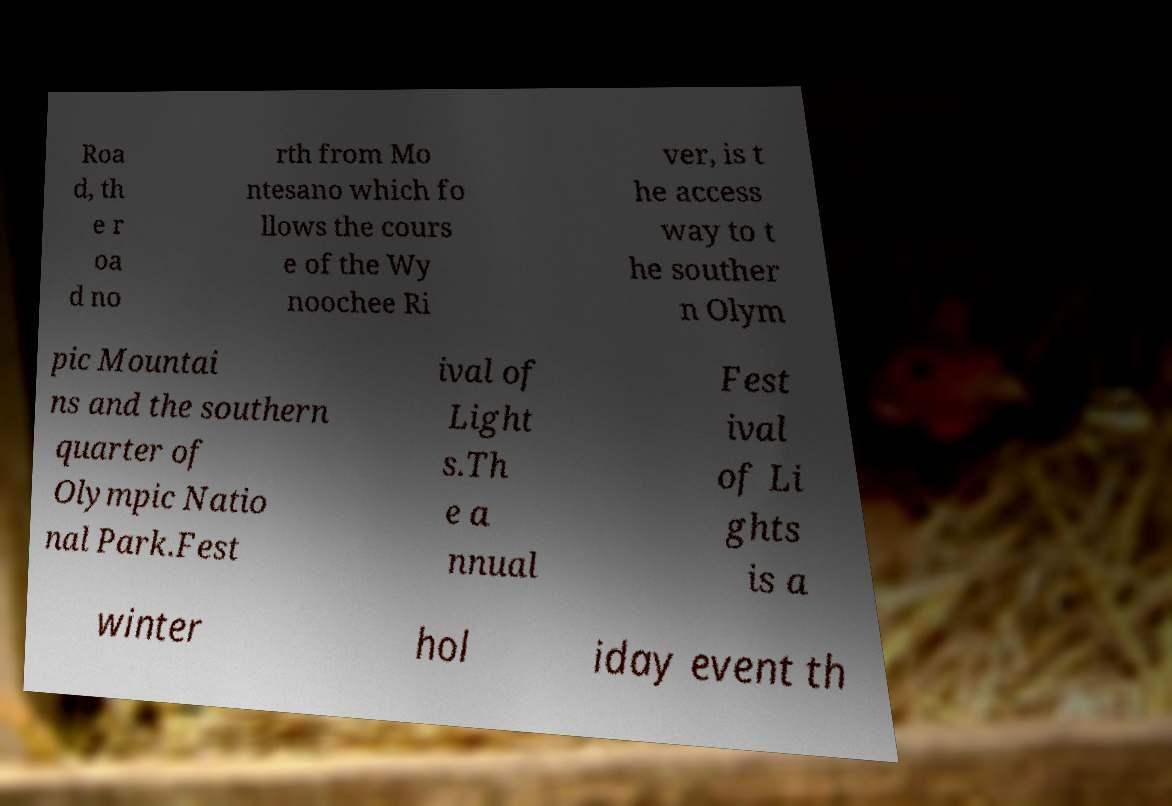Can you read and provide the text displayed in the image?This photo seems to have some interesting text. Can you extract and type it out for me? Roa d, th e r oa d no rth from Mo ntesano which fo llows the cours e of the Wy noochee Ri ver, is t he access way to t he souther n Olym pic Mountai ns and the southern quarter of Olympic Natio nal Park.Fest ival of Light s.Th e a nnual Fest ival of Li ghts is a winter hol iday event th 